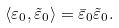Convert formula to latex. <formula><loc_0><loc_0><loc_500><loc_500>\langle \varepsilon _ { 0 } , \tilde { \varepsilon } _ { 0 } \rangle = \bar { \varepsilon } _ { 0 } \tilde { \varepsilon } _ { 0 } .</formula> 